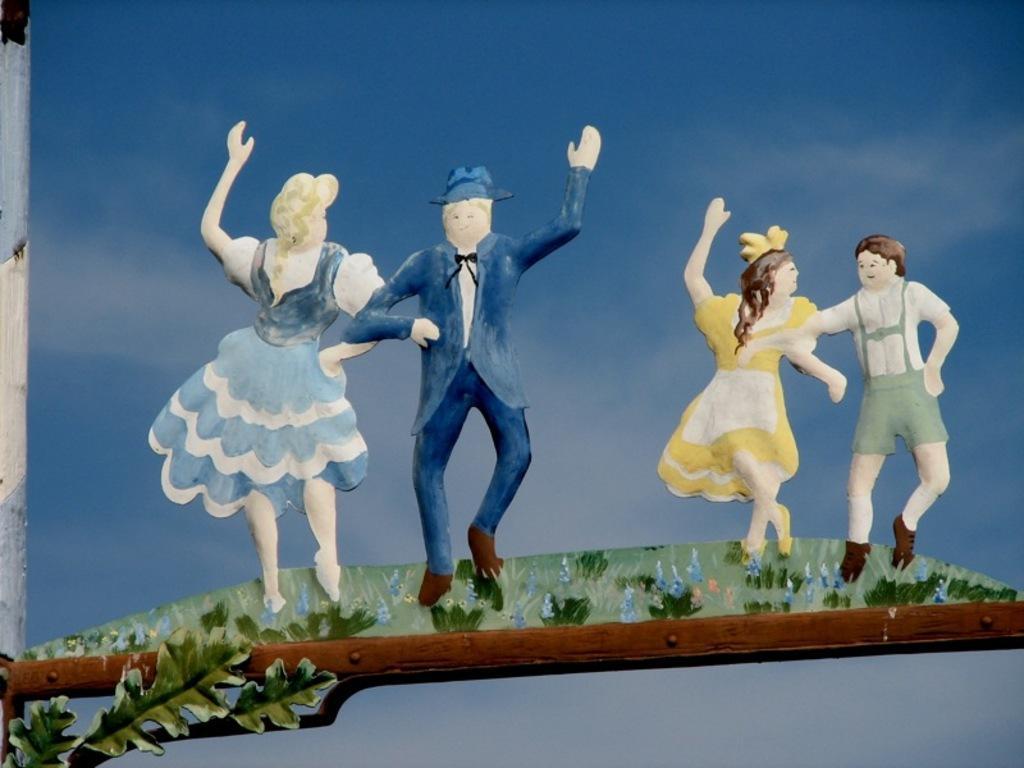Can you describe this image briefly? In this image there is a painting, in the painting there are two couples standing on the grass surface, in front of them there is a leaf and a wooden platform. 